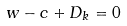<formula> <loc_0><loc_0><loc_500><loc_500>w - c + D _ { k } = 0</formula> 